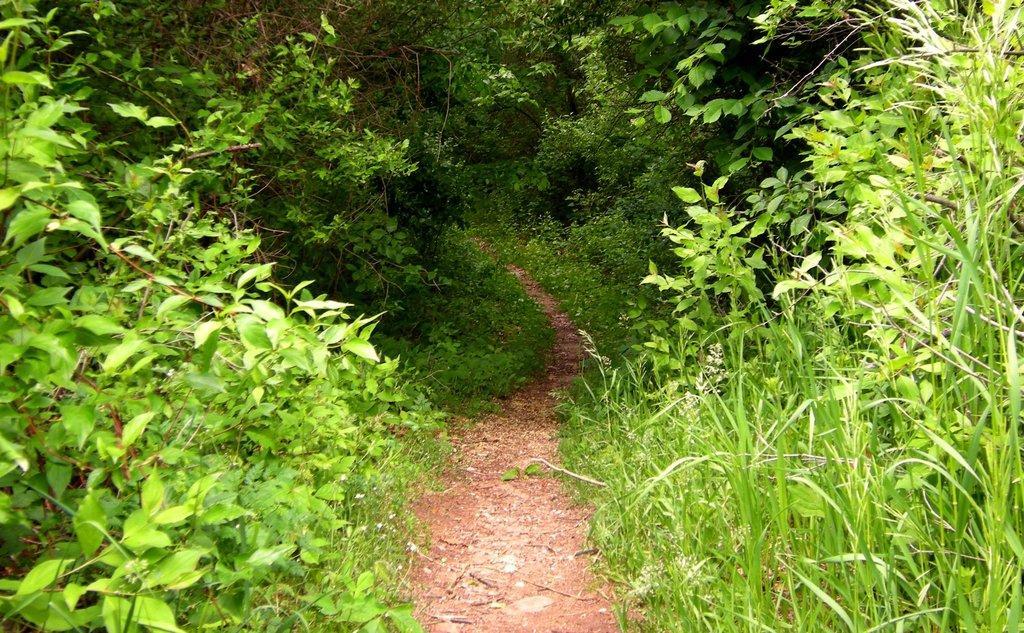Describe this image in one or two sentences. This picture shows trees and plants and we see a path. 